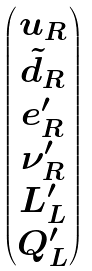<formula> <loc_0><loc_0><loc_500><loc_500>\begin{pmatrix} u _ { R } \\ \tilde { d } _ { R } \\ e _ { R } ^ { \prime } \\ \nu _ { R } ^ { \prime } \\ L ^ { \prime } _ { L } \\ Q ^ { \prime } _ { L } \\ \end{pmatrix}</formula> 